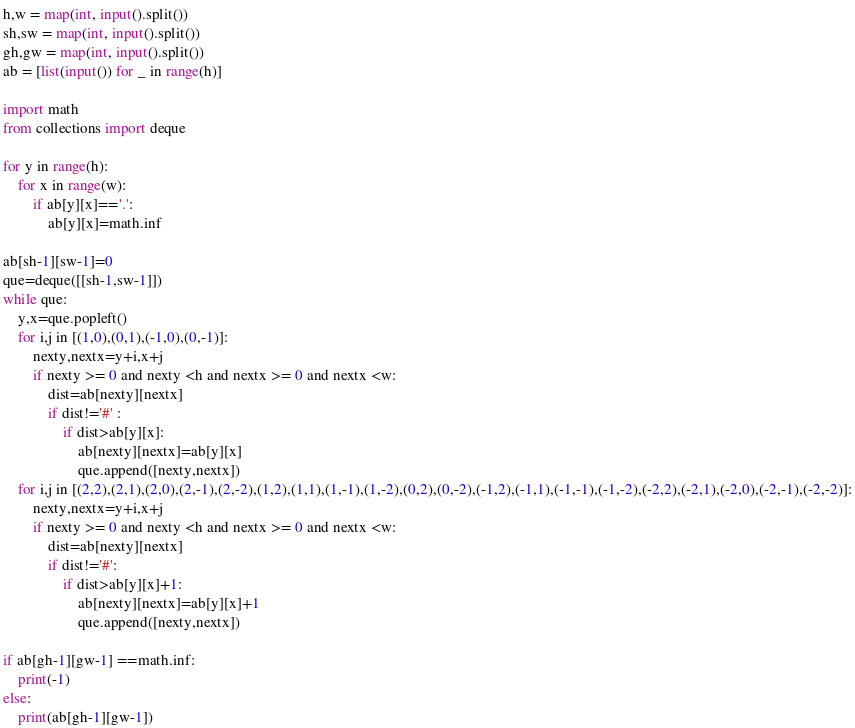<code> <loc_0><loc_0><loc_500><loc_500><_Python_>h,w = map(int, input().split())
sh,sw = map(int, input().split())
gh,gw = map(int, input().split())
ab = [list(input()) for _ in range(h)]

import math
from collections import deque

for y in range(h):
    for x in range(w):
        if ab[y][x]=='.':
            ab[y][x]=math.inf

ab[sh-1][sw-1]=0
que=deque([[sh-1,sw-1]])
while que:
    y,x=que.popleft()
    for i,j in [(1,0),(0,1),(-1,0),(0,-1)]:
        nexty,nextx=y+i,x+j
        if nexty >= 0 and nexty <h and nextx >= 0 and nextx <w:
            dist=ab[nexty][nextx]
            if dist!='#' :
                if dist>ab[y][x]:
                    ab[nexty][nextx]=ab[y][x]
                    que.append([nexty,nextx])
    for i,j in [(2,2),(2,1),(2,0),(2,-1),(2,-2),(1,2),(1,1),(1,-1),(1,-2),(0,2),(0,-2),(-1,2),(-1,1),(-1,-1),(-1,-2),(-2,2),(-2,1),(-2,0),(-2,-1),(-2,-2)]:
        nexty,nextx=y+i,x+j
        if nexty >= 0 and nexty <h and nextx >= 0 and nextx <w:
            dist=ab[nexty][nextx]
            if dist!='#':
                if dist>ab[y][x]+1:
                    ab[nexty][nextx]=ab[y][x]+1
                    que.append([nexty,nextx])

if ab[gh-1][gw-1] ==math.inf:
    print(-1)
else:
    print(ab[gh-1][gw-1])</code> 